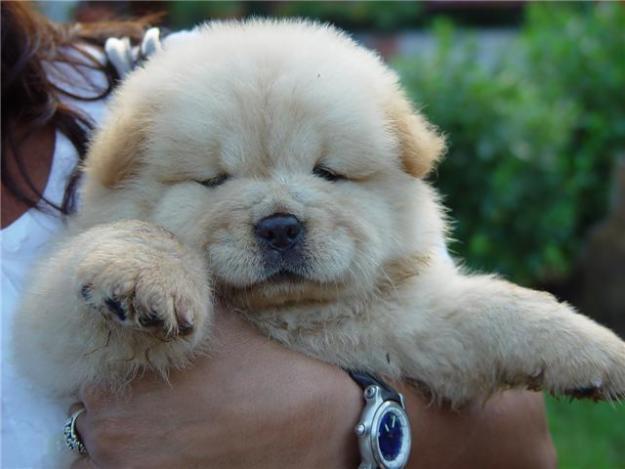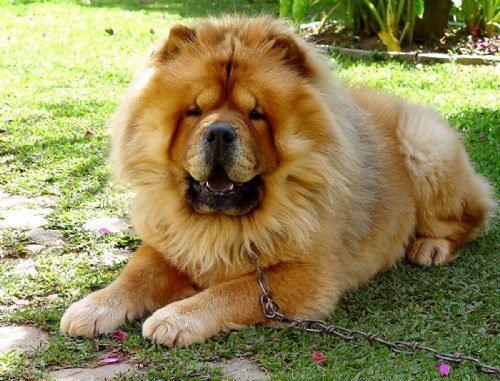The first image is the image on the left, the second image is the image on the right. Assess this claim about the two images: "The left and right image contains the same number of dogs with one being held in a woman's arms.". Correct or not? Answer yes or no. Yes. The first image is the image on the left, the second image is the image on the right. Considering the images on both sides, is "A dog is laying in grass." valid? Answer yes or no. Yes. 